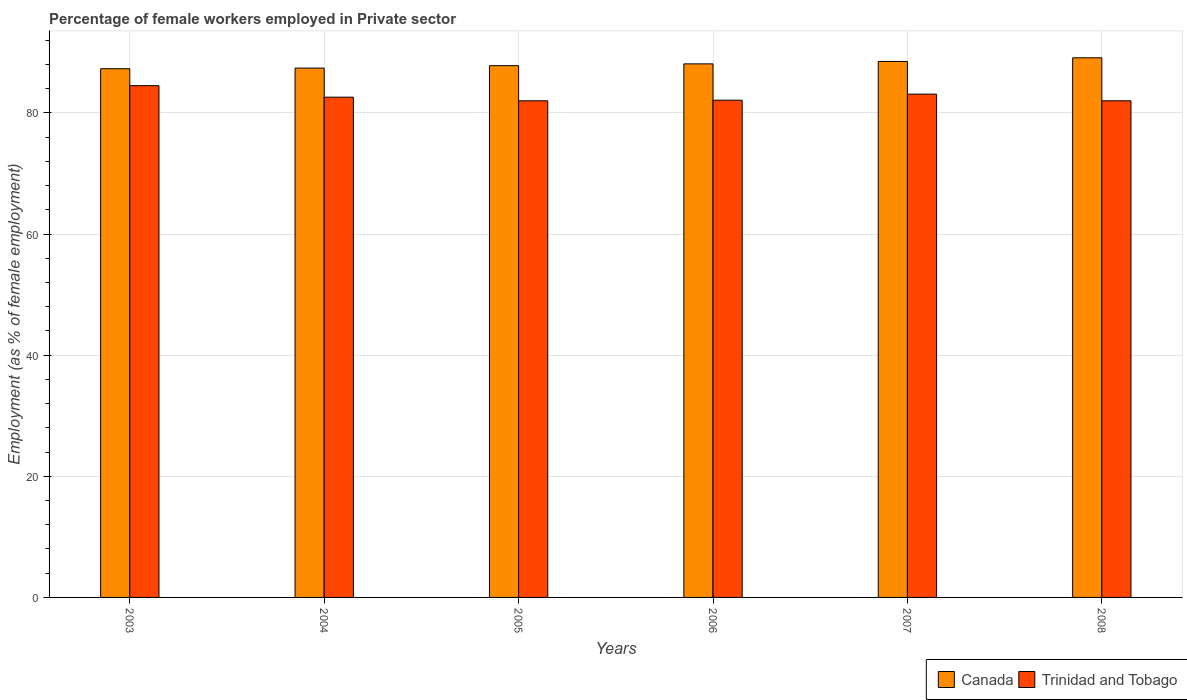How many different coloured bars are there?
Your answer should be compact. 2. How many groups of bars are there?
Your response must be concise. 6. How many bars are there on the 2nd tick from the left?
Offer a terse response. 2. How many bars are there on the 4th tick from the right?
Give a very brief answer. 2. In how many cases, is the number of bars for a given year not equal to the number of legend labels?
Make the answer very short. 0. What is the percentage of females employed in Private sector in Trinidad and Tobago in 2003?
Your answer should be compact. 84.5. Across all years, what is the maximum percentage of females employed in Private sector in Canada?
Ensure brevity in your answer.  89.1. Across all years, what is the minimum percentage of females employed in Private sector in Trinidad and Tobago?
Your answer should be compact. 82. In which year was the percentage of females employed in Private sector in Trinidad and Tobago minimum?
Give a very brief answer. 2005. What is the total percentage of females employed in Private sector in Canada in the graph?
Give a very brief answer. 528.2. What is the difference between the percentage of females employed in Private sector in Trinidad and Tobago in 2004 and that in 2005?
Provide a short and direct response. 0.6. What is the difference between the percentage of females employed in Private sector in Trinidad and Tobago in 2007 and the percentage of females employed in Private sector in Canada in 2005?
Your response must be concise. -4.7. What is the average percentage of females employed in Private sector in Canada per year?
Keep it short and to the point. 88.03. In the year 2006, what is the difference between the percentage of females employed in Private sector in Trinidad and Tobago and percentage of females employed in Private sector in Canada?
Your answer should be compact. -6. In how many years, is the percentage of females employed in Private sector in Trinidad and Tobago greater than 68 %?
Give a very brief answer. 6. What is the ratio of the percentage of females employed in Private sector in Canada in 2007 to that in 2008?
Make the answer very short. 0.99. Is the percentage of females employed in Private sector in Canada in 2006 less than that in 2008?
Your answer should be compact. Yes. Is the difference between the percentage of females employed in Private sector in Trinidad and Tobago in 2004 and 2007 greater than the difference between the percentage of females employed in Private sector in Canada in 2004 and 2007?
Keep it short and to the point. Yes. What is the difference between the highest and the second highest percentage of females employed in Private sector in Canada?
Ensure brevity in your answer.  0.6. What is the difference between the highest and the lowest percentage of females employed in Private sector in Canada?
Give a very brief answer. 1.8. In how many years, is the percentage of females employed in Private sector in Canada greater than the average percentage of females employed in Private sector in Canada taken over all years?
Keep it short and to the point. 3. What does the 2nd bar from the left in 2004 represents?
Your answer should be compact. Trinidad and Tobago. What does the 2nd bar from the right in 2007 represents?
Your answer should be very brief. Canada. How many bars are there?
Give a very brief answer. 12. How many years are there in the graph?
Offer a very short reply. 6. What is the difference between two consecutive major ticks on the Y-axis?
Provide a short and direct response. 20. Does the graph contain any zero values?
Give a very brief answer. No. What is the title of the graph?
Give a very brief answer. Percentage of female workers employed in Private sector. Does "St. Vincent and the Grenadines" appear as one of the legend labels in the graph?
Your answer should be very brief. No. What is the label or title of the Y-axis?
Your response must be concise. Employment (as % of female employment). What is the Employment (as % of female employment) in Canada in 2003?
Provide a succinct answer. 87.3. What is the Employment (as % of female employment) in Trinidad and Tobago in 2003?
Make the answer very short. 84.5. What is the Employment (as % of female employment) in Canada in 2004?
Offer a terse response. 87.4. What is the Employment (as % of female employment) of Trinidad and Tobago in 2004?
Your response must be concise. 82.6. What is the Employment (as % of female employment) in Canada in 2005?
Your answer should be very brief. 87.8. What is the Employment (as % of female employment) of Canada in 2006?
Your answer should be very brief. 88.1. What is the Employment (as % of female employment) in Trinidad and Tobago in 2006?
Your response must be concise. 82.1. What is the Employment (as % of female employment) in Canada in 2007?
Your response must be concise. 88.5. What is the Employment (as % of female employment) in Trinidad and Tobago in 2007?
Provide a succinct answer. 83.1. What is the Employment (as % of female employment) in Canada in 2008?
Give a very brief answer. 89.1. What is the Employment (as % of female employment) of Trinidad and Tobago in 2008?
Give a very brief answer. 82. Across all years, what is the maximum Employment (as % of female employment) in Canada?
Your answer should be compact. 89.1. Across all years, what is the maximum Employment (as % of female employment) in Trinidad and Tobago?
Your answer should be very brief. 84.5. Across all years, what is the minimum Employment (as % of female employment) of Canada?
Provide a short and direct response. 87.3. What is the total Employment (as % of female employment) of Canada in the graph?
Provide a short and direct response. 528.2. What is the total Employment (as % of female employment) of Trinidad and Tobago in the graph?
Ensure brevity in your answer.  496.3. What is the difference between the Employment (as % of female employment) in Canada in 2003 and that in 2004?
Keep it short and to the point. -0.1. What is the difference between the Employment (as % of female employment) in Canada in 2003 and that in 2005?
Your answer should be compact. -0.5. What is the difference between the Employment (as % of female employment) in Canada in 2003 and that in 2006?
Keep it short and to the point. -0.8. What is the difference between the Employment (as % of female employment) of Trinidad and Tobago in 2003 and that in 2006?
Provide a succinct answer. 2.4. What is the difference between the Employment (as % of female employment) of Trinidad and Tobago in 2003 and that in 2007?
Keep it short and to the point. 1.4. What is the difference between the Employment (as % of female employment) of Canada in 2003 and that in 2008?
Provide a short and direct response. -1.8. What is the difference between the Employment (as % of female employment) in Trinidad and Tobago in 2003 and that in 2008?
Provide a succinct answer. 2.5. What is the difference between the Employment (as % of female employment) of Canada in 2004 and that in 2005?
Give a very brief answer. -0.4. What is the difference between the Employment (as % of female employment) in Trinidad and Tobago in 2004 and that in 2005?
Ensure brevity in your answer.  0.6. What is the difference between the Employment (as % of female employment) of Canada in 2004 and that in 2006?
Give a very brief answer. -0.7. What is the difference between the Employment (as % of female employment) of Trinidad and Tobago in 2004 and that in 2006?
Ensure brevity in your answer.  0.5. What is the difference between the Employment (as % of female employment) of Canada in 2004 and that in 2007?
Keep it short and to the point. -1.1. What is the difference between the Employment (as % of female employment) of Trinidad and Tobago in 2004 and that in 2008?
Offer a very short reply. 0.6. What is the difference between the Employment (as % of female employment) of Trinidad and Tobago in 2005 and that in 2006?
Give a very brief answer. -0.1. What is the difference between the Employment (as % of female employment) of Canada in 2005 and that in 2007?
Provide a short and direct response. -0.7. What is the difference between the Employment (as % of female employment) in Trinidad and Tobago in 2005 and that in 2007?
Your answer should be compact. -1.1. What is the difference between the Employment (as % of female employment) of Canada in 2005 and that in 2008?
Give a very brief answer. -1.3. What is the difference between the Employment (as % of female employment) in Trinidad and Tobago in 2005 and that in 2008?
Ensure brevity in your answer.  0. What is the difference between the Employment (as % of female employment) of Canada in 2006 and that in 2007?
Make the answer very short. -0.4. What is the difference between the Employment (as % of female employment) in Trinidad and Tobago in 2006 and that in 2007?
Offer a terse response. -1. What is the difference between the Employment (as % of female employment) in Canada in 2006 and that in 2008?
Offer a terse response. -1. What is the difference between the Employment (as % of female employment) in Trinidad and Tobago in 2006 and that in 2008?
Give a very brief answer. 0.1. What is the difference between the Employment (as % of female employment) of Trinidad and Tobago in 2007 and that in 2008?
Ensure brevity in your answer.  1.1. What is the difference between the Employment (as % of female employment) in Canada in 2003 and the Employment (as % of female employment) in Trinidad and Tobago in 2004?
Give a very brief answer. 4.7. What is the difference between the Employment (as % of female employment) in Canada in 2003 and the Employment (as % of female employment) in Trinidad and Tobago in 2006?
Your answer should be compact. 5.2. What is the difference between the Employment (as % of female employment) in Canada in 2003 and the Employment (as % of female employment) in Trinidad and Tobago in 2007?
Provide a short and direct response. 4.2. What is the difference between the Employment (as % of female employment) in Canada in 2003 and the Employment (as % of female employment) in Trinidad and Tobago in 2008?
Make the answer very short. 5.3. What is the difference between the Employment (as % of female employment) in Canada in 2004 and the Employment (as % of female employment) in Trinidad and Tobago in 2005?
Ensure brevity in your answer.  5.4. What is the difference between the Employment (as % of female employment) in Canada in 2004 and the Employment (as % of female employment) in Trinidad and Tobago in 2006?
Give a very brief answer. 5.3. What is the difference between the Employment (as % of female employment) of Canada in 2005 and the Employment (as % of female employment) of Trinidad and Tobago in 2006?
Your response must be concise. 5.7. What is the difference between the Employment (as % of female employment) in Canada in 2005 and the Employment (as % of female employment) in Trinidad and Tobago in 2008?
Offer a very short reply. 5.8. What is the difference between the Employment (as % of female employment) in Canada in 2006 and the Employment (as % of female employment) in Trinidad and Tobago in 2008?
Give a very brief answer. 6.1. What is the average Employment (as % of female employment) in Canada per year?
Keep it short and to the point. 88.03. What is the average Employment (as % of female employment) in Trinidad and Tobago per year?
Your response must be concise. 82.72. In the year 2003, what is the difference between the Employment (as % of female employment) in Canada and Employment (as % of female employment) in Trinidad and Tobago?
Your response must be concise. 2.8. In the year 2004, what is the difference between the Employment (as % of female employment) of Canada and Employment (as % of female employment) of Trinidad and Tobago?
Your response must be concise. 4.8. In the year 2005, what is the difference between the Employment (as % of female employment) in Canada and Employment (as % of female employment) in Trinidad and Tobago?
Make the answer very short. 5.8. In the year 2007, what is the difference between the Employment (as % of female employment) of Canada and Employment (as % of female employment) of Trinidad and Tobago?
Your response must be concise. 5.4. What is the ratio of the Employment (as % of female employment) of Canada in 2003 to that in 2004?
Offer a terse response. 1. What is the ratio of the Employment (as % of female employment) of Trinidad and Tobago in 2003 to that in 2004?
Offer a terse response. 1.02. What is the ratio of the Employment (as % of female employment) of Trinidad and Tobago in 2003 to that in 2005?
Provide a short and direct response. 1.03. What is the ratio of the Employment (as % of female employment) in Canada in 2003 to that in 2006?
Give a very brief answer. 0.99. What is the ratio of the Employment (as % of female employment) of Trinidad and Tobago in 2003 to that in 2006?
Offer a very short reply. 1.03. What is the ratio of the Employment (as % of female employment) of Canada in 2003 to that in 2007?
Give a very brief answer. 0.99. What is the ratio of the Employment (as % of female employment) in Trinidad and Tobago in 2003 to that in 2007?
Provide a succinct answer. 1.02. What is the ratio of the Employment (as % of female employment) in Canada in 2003 to that in 2008?
Your answer should be very brief. 0.98. What is the ratio of the Employment (as % of female employment) in Trinidad and Tobago in 2003 to that in 2008?
Your answer should be very brief. 1.03. What is the ratio of the Employment (as % of female employment) in Canada in 2004 to that in 2005?
Your answer should be compact. 1. What is the ratio of the Employment (as % of female employment) in Trinidad and Tobago in 2004 to that in 2005?
Provide a succinct answer. 1.01. What is the ratio of the Employment (as % of female employment) of Trinidad and Tobago in 2004 to that in 2006?
Give a very brief answer. 1.01. What is the ratio of the Employment (as % of female employment) in Canada in 2004 to that in 2007?
Offer a terse response. 0.99. What is the ratio of the Employment (as % of female employment) in Canada in 2004 to that in 2008?
Offer a very short reply. 0.98. What is the ratio of the Employment (as % of female employment) of Trinidad and Tobago in 2004 to that in 2008?
Ensure brevity in your answer.  1.01. What is the ratio of the Employment (as % of female employment) of Canada in 2005 to that in 2006?
Ensure brevity in your answer.  1. What is the ratio of the Employment (as % of female employment) of Trinidad and Tobago in 2005 to that in 2006?
Offer a terse response. 1. What is the ratio of the Employment (as % of female employment) in Trinidad and Tobago in 2005 to that in 2007?
Give a very brief answer. 0.99. What is the ratio of the Employment (as % of female employment) of Canada in 2005 to that in 2008?
Your answer should be compact. 0.99. What is the ratio of the Employment (as % of female employment) in Trinidad and Tobago in 2005 to that in 2008?
Your response must be concise. 1. What is the ratio of the Employment (as % of female employment) in Canada in 2006 to that in 2007?
Your answer should be very brief. 1. What is the ratio of the Employment (as % of female employment) in Trinidad and Tobago in 2006 to that in 2007?
Keep it short and to the point. 0.99. What is the ratio of the Employment (as % of female employment) in Trinidad and Tobago in 2006 to that in 2008?
Your answer should be compact. 1. What is the ratio of the Employment (as % of female employment) of Trinidad and Tobago in 2007 to that in 2008?
Keep it short and to the point. 1.01. What is the difference between the highest and the second highest Employment (as % of female employment) in Trinidad and Tobago?
Offer a terse response. 1.4. 